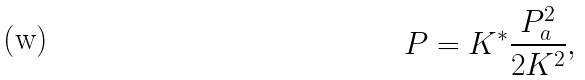Convert formula to latex. <formula><loc_0><loc_0><loc_500><loc_500>P = K ^ { * } \frac { P _ { a } ^ { 2 } } { 2 K ^ { 2 } } ,</formula> 